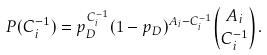<formula> <loc_0><loc_0><loc_500><loc_500>P ( C ^ { - 1 } _ { i } ) = p _ { D } ^ { C ^ { - 1 } _ { i } } ( 1 - p _ { D } ) ^ { A _ { i } - C ^ { - 1 } _ { i } } \binom { A _ { i } } { C ^ { - 1 } _ { i } } .</formula> 